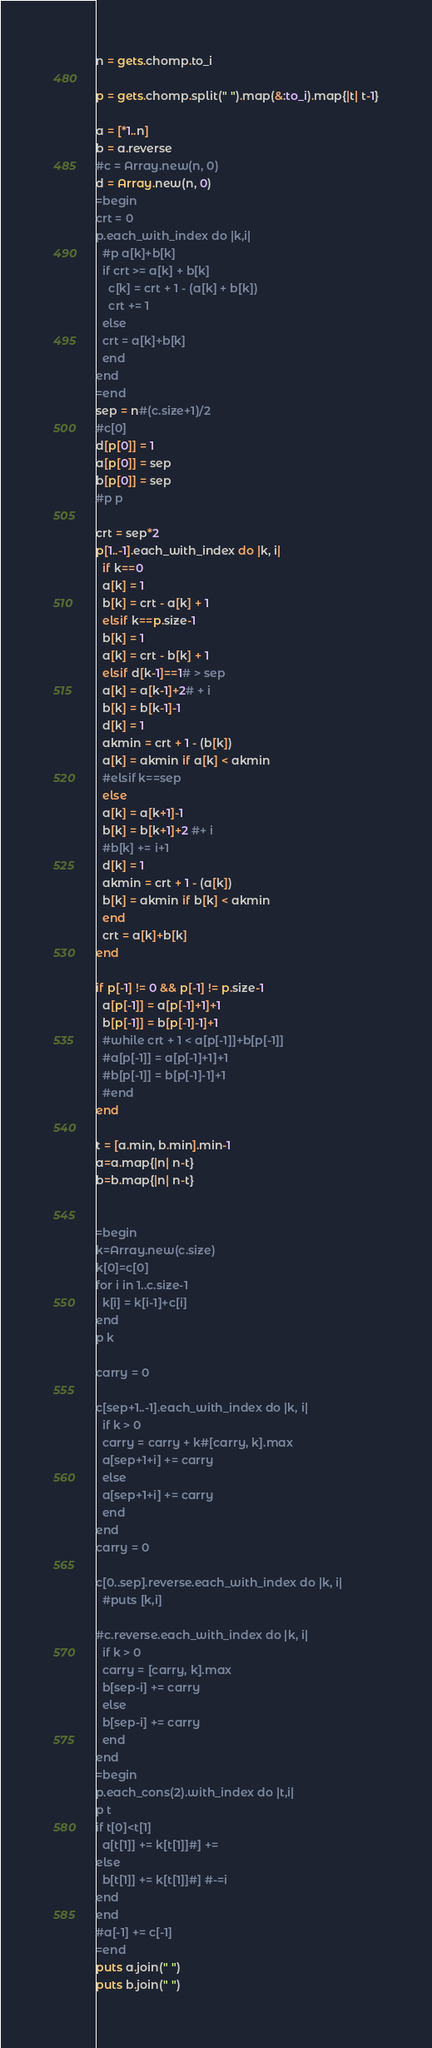Convert code to text. <code><loc_0><loc_0><loc_500><loc_500><_Ruby_>
n = gets.chomp.to_i

p = gets.chomp.split(" ").map(&:to_i).map{|t| t-1}

a = [*1..n]
b = a.reverse
#c = Array.new(n, 0)
d = Array.new(n, 0)
=begin
crt = 0
p.each_with_index do |k,i|
  #p a[k]+b[k]
  if crt >= a[k] + b[k]
    c[k] = crt + 1 - (a[k] + b[k])
    crt += 1
  else
  crt = a[k]+b[k]
  end 
end
=end
sep = n#(c.size+1)/2
#c[0]
d[p[0]] = 1
a[p[0]] = sep
b[p[0]] = sep
#p p

crt = sep*2
p[1..-1].each_with_index do |k, i|
  if k==0
  a[k] = 1
  b[k] = crt - a[k] + 1
  elsif k==p.size-1
  b[k] = 1
  a[k] = crt - b[k] + 1
  elsif d[k-1]==1# > sep
  a[k] = a[k-1]+2# + i
  b[k] = b[k-1]-1
  d[k] = 1
  akmin = crt + 1 - (b[k]) 
  a[k] = akmin if a[k] < akmin
  #elsif k==sep
  else
  a[k] = a[k+1]-1
  b[k] = b[k+1]+2 #+ i
  #b[k] += i+1
  d[k] = 1
  akmin = crt + 1 - (a[k]) 
  b[k] = akmin if b[k] < akmin
  end
  crt = a[k]+b[k]
end

if p[-1] != 0 && p[-1] != p.size-1
  a[p[-1]] = a[p[-1]+1]+1
  b[p[-1]] = b[p[-1]-1]+1
  #while crt + 1 < a[p[-1]]+b[p[-1]]
  #a[p[-1]] = a[p[-1]+1]+1
  #b[p[-1]] = b[p[-1]-1]+1
  #end
end

t = [a.min, b.min].min-1
a=a.map{|n| n-t}
b=b.map{|n| n-t}


=begin
k=Array.new(c.size)
k[0]=c[0]
for i in 1..c.size-1
  k[i] = k[i-1]+c[i]
end
p k

carry = 0

c[sep+1..-1].each_with_index do |k, i|
  if k > 0
  carry = carry + k#[carry, k].max
  a[sep+1+i] += carry
  else
  a[sep+1+i] += carry
  end
end
carry = 0

c[0..sep].reverse.each_with_index do |k, i|
  #puts [k,i]

#c.reverse.each_with_index do |k, i|
  if k > 0
  carry = [carry, k].max
  b[sep-i] += carry
  else
  b[sep-i] += carry
  end
end
=begin
p.each_cons(2).with_index do |t,i|
p t
if t[0]<t[1]
  a[t[1]] += k[t[1]]#] += 
else
  b[t[1]] += k[t[1]]#] #-=i
end
end
#a[-1] += c[-1]
=end
puts a.join(" ")
puts b.join(" ")
</code> 